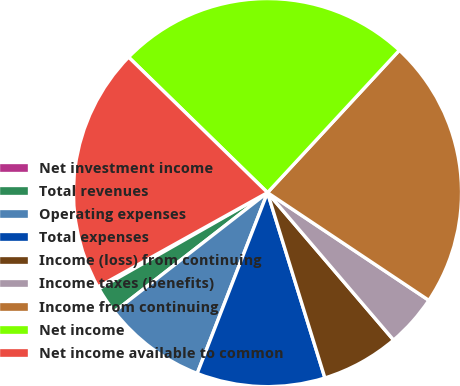Convert chart. <chart><loc_0><loc_0><loc_500><loc_500><pie_chart><fcel>Net investment income<fcel>Total revenues<fcel>Operating expenses<fcel>Total expenses<fcel>Income (loss) from continuing<fcel>Income taxes (benefits)<fcel>Income from continuing<fcel>Net income<fcel>Net income available to common<nl><fcel>0.17%<fcel>2.27%<fcel>8.58%<fcel>10.68%<fcel>6.48%<fcel>4.37%<fcel>22.48%<fcel>24.59%<fcel>20.38%<nl></chart> 